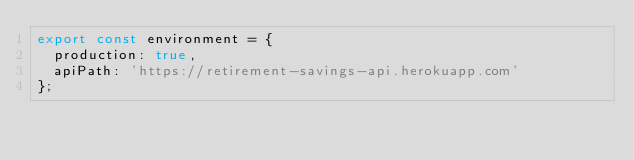<code> <loc_0><loc_0><loc_500><loc_500><_TypeScript_>export const environment = {
  production: true,
  apiPath: 'https://retirement-savings-api.herokuapp.com'
};
</code> 